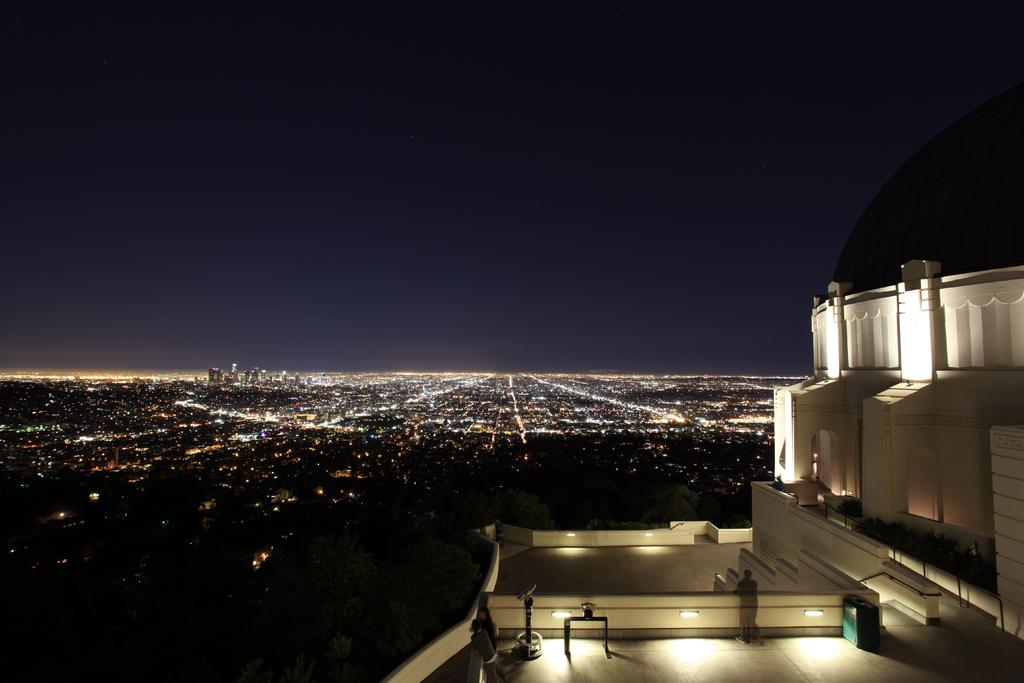What type of structure is visible in the image? There is a building in the image. What are some features of the building? The building has walls and lights. Can you describe the people in the image? There are people standing in the image. What else can be seen in the image besides the building and people? There are objects and plants in the image. What is visible in the background of the image? The background of the image includes light and the sky. How many hats can be seen on the people in the image? There is no mention of hats in the image, so it is impossible to determine how many hats are present. 